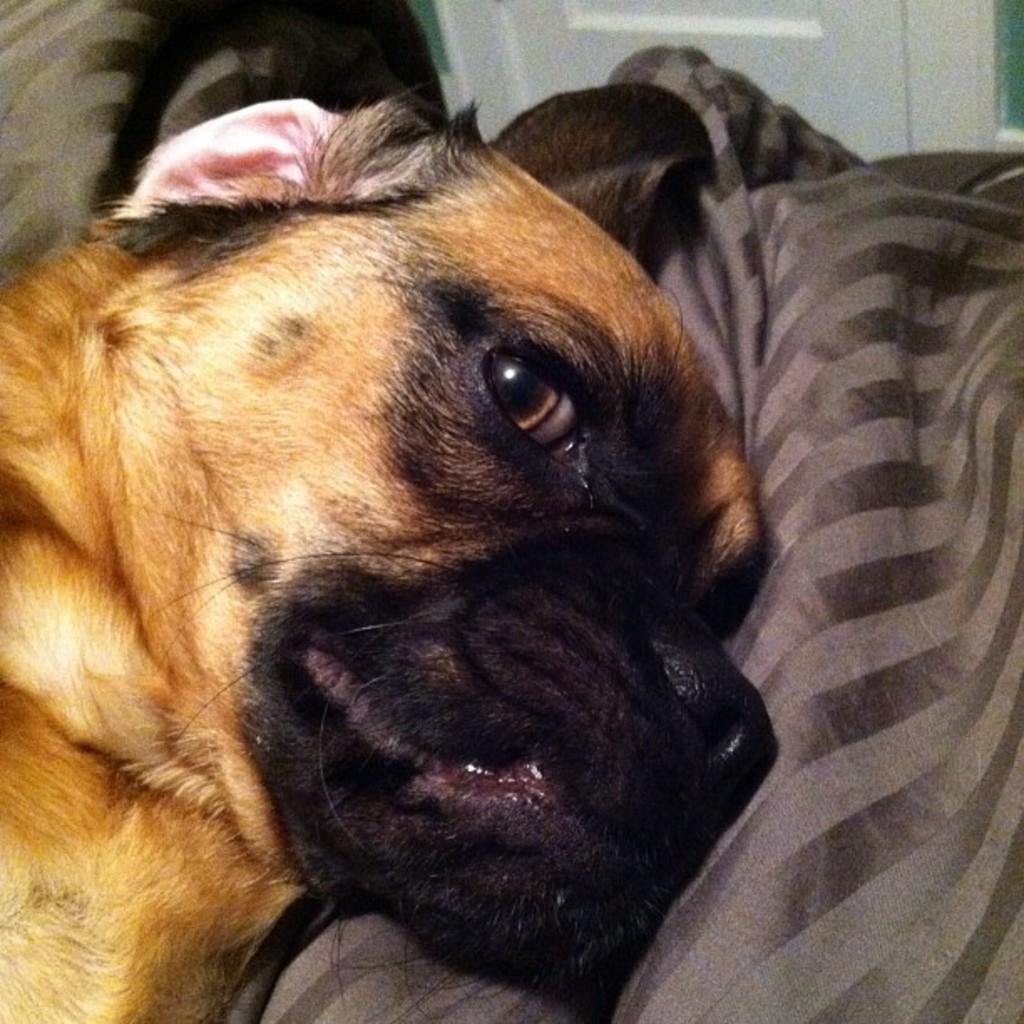How would you summarize this image in a sentence or two? In this image we can a dog on the cloth and there is a door in the background. 